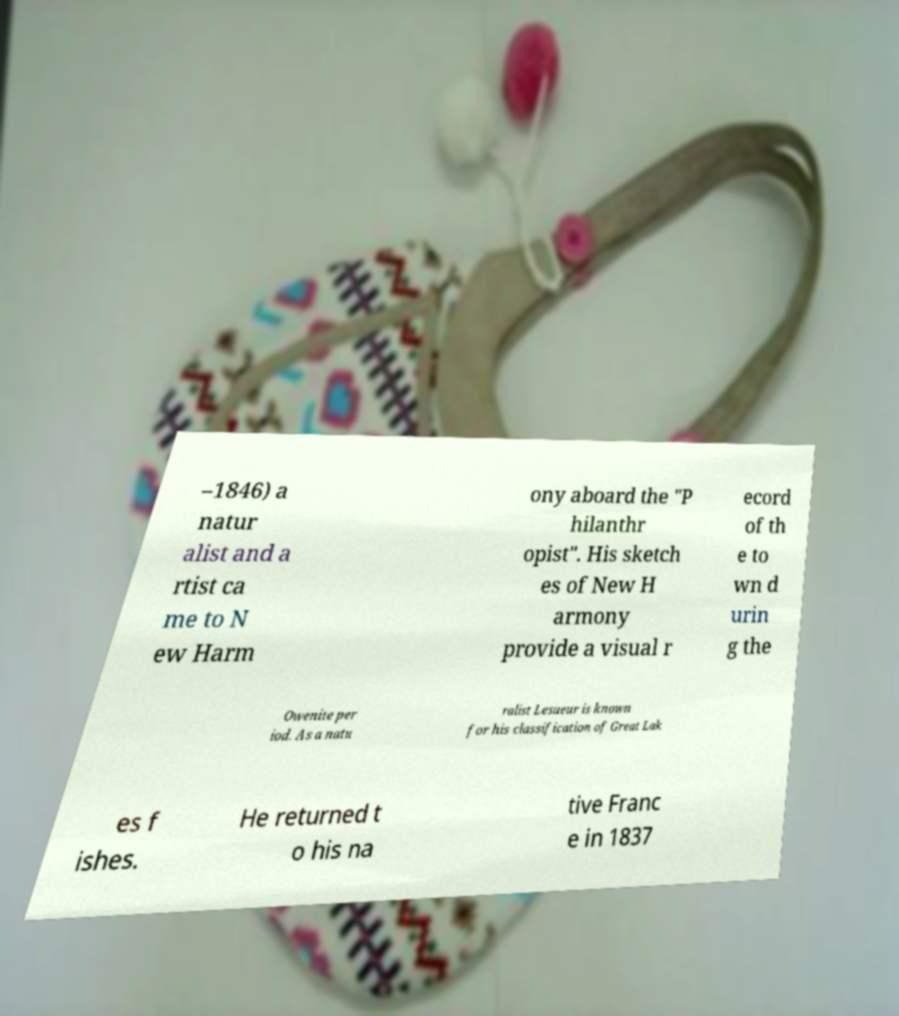What messages or text are displayed in this image? I need them in a readable, typed format. –1846) a natur alist and a rtist ca me to N ew Harm ony aboard the "P hilanthr opist". His sketch es of New H armony provide a visual r ecord of th e to wn d urin g the Owenite per iod. As a natu ralist Lesueur is known for his classification of Great Lak es f ishes. He returned t o his na tive Franc e in 1837 